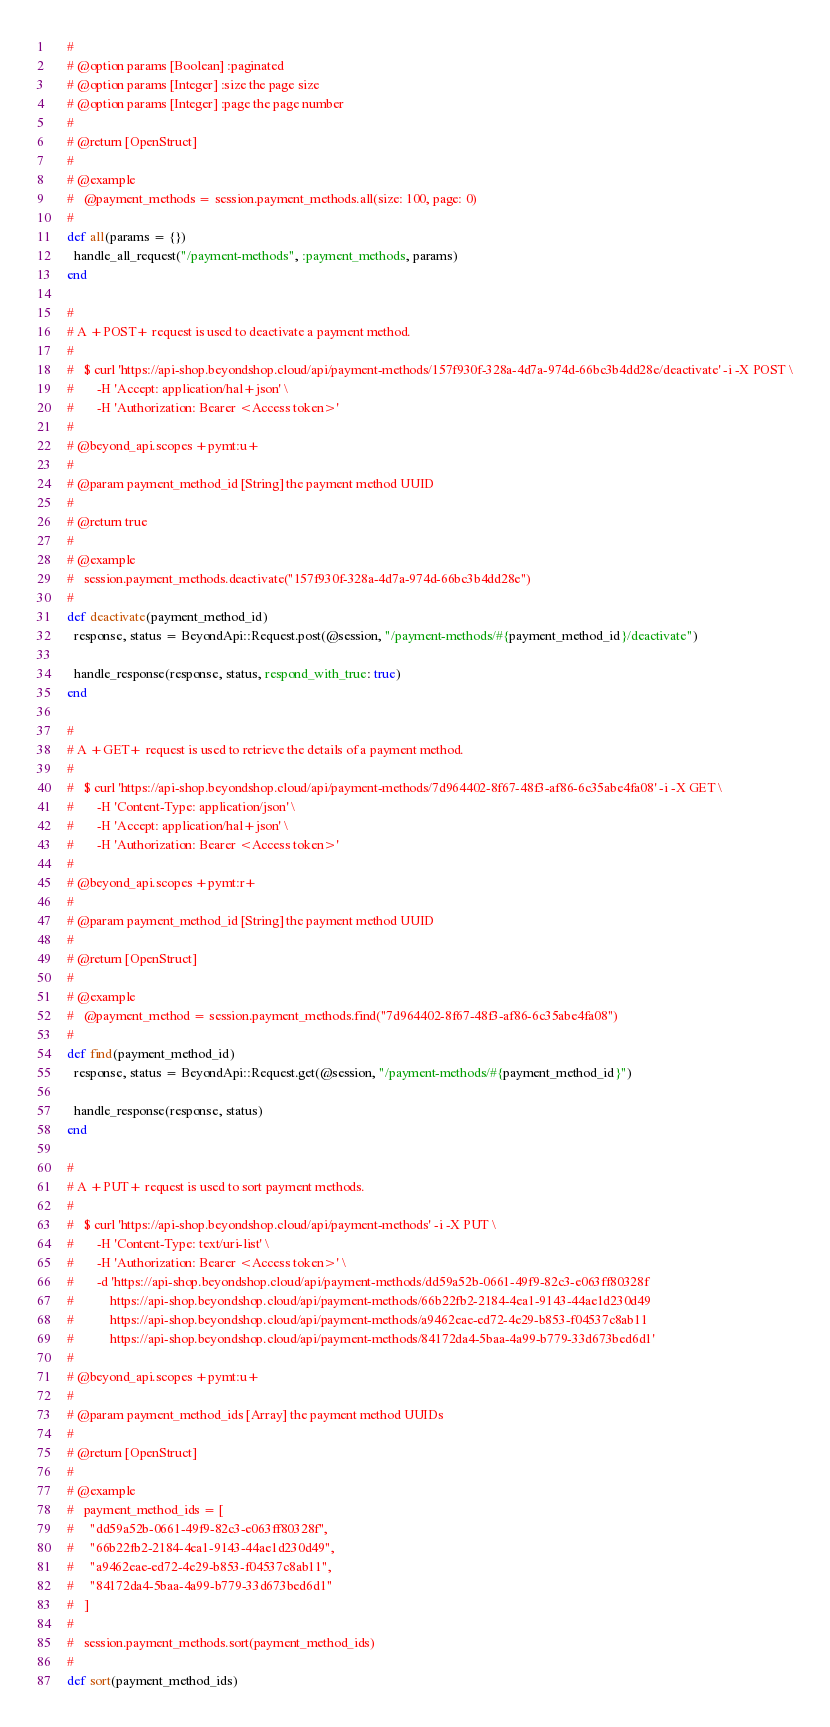<code> <loc_0><loc_0><loc_500><loc_500><_Ruby_>    #
    # @option params [Boolean] :paginated
    # @option params [Integer] :size the page size
    # @option params [Integer] :page the page number
    #
    # @return [OpenStruct]
    #
    # @example
    #   @payment_methods = session.payment_methods.all(size: 100, page: 0)
    #
    def all(params = {})
      handle_all_request("/payment-methods", :payment_methods, params)
    end

    #
    # A +POST+ request is used to deactivate a payment method.
    #
    #   $ curl 'https://api-shop.beyondshop.cloud/api/payment-methods/157f930f-328a-4d7a-974d-66bc3b4dd28e/deactivate' -i -X POST \
    #       -H 'Accept: application/hal+json' \
    #       -H 'Authorization: Bearer <Access token>'
    #
    # @beyond_api.scopes +pymt:u+
    #
    # @param payment_method_id [String] the payment method UUID
    #
    # @return true
    #
    # @example
    #   session.payment_methods.deactivate("157f930f-328a-4d7a-974d-66bc3b4dd28e")
    #
    def deactivate(payment_method_id)
      response, status = BeyondApi::Request.post(@session, "/payment-methods/#{payment_method_id}/deactivate")

      handle_response(response, status, respond_with_true: true)
    end

    #
    # A +GET+ request is used to retrieve the details of a payment method.
    #
    #   $ curl 'https://api-shop.beyondshop.cloud/api/payment-methods/7d964402-8f67-48f3-af86-6c35abe4fa08' -i -X GET \
    #       -H 'Content-Type: application/json' \
    #       -H 'Accept: application/hal+json' \
    #       -H 'Authorization: Bearer <Access token>'
    #
    # @beyond_api.scopes +pymt:r+
    #
    # @param payment_method_id [String] the payment method UUID
    #
    # @return [OpenStruct]
    #
    # @example
    #   @payment_method = session.payment_methods.find("7d964402-8f67-48f3-af86-6c35abe4fa08")
    #
    def find(payment_method_id)
      response, status = BeyondApi::Request.get(@session, "/payment-methods/#{payment_method_id}")

      handle_response(response, status)
    end

    #
    # A +PUT+ request is used to sort payment methods.
    #
    #   $ curl 'https://api-shop.beyondshop.cloud/api/payment-methods' -i -X PUT \
    #       -H 'Content-Type: text/uri-list' \
    #       -H 'Authorization: Bearer <Access token>' \
    #       -d 'https://api-shop.beyondshop.cloud/api/payment-methods/dd59a52b-0661-49f9-82c3-e063ff80328f
    #           https://api-shop.beyondshop.cloud/api/payment-methods/66b22fb2-2184-4ea1-9143-44ae1d230d49
    #           https://api-shop.beyondshop.cloud/api/payment-methods/a9462eae-ed72-4e29-b853-f04537c8ab11
    #           https://api-shop.beyondshop.cloud/api/payment-methods/84172da4-5baa-4a99-b779-33d673bed6d1'
    #
    # @beyond_api.scopes +pymt:u+
    #
    # @param payment_method_ids [Array] the payment method UUIDs
    #
    # @return [OpenStruct]
    #
    # @example
    #   payment_method_ids = [
    #     "dd59a52b-0661-49f9-82c3-e063ff80328f",
    #     "66b22fb2-2184-4ea1-9143-44ae1d230d49",
    #     "a9462eae-ed72-4e29-b853-f04537c8ab11",
    #     "84172da4-5baa-4a99-b779-33d673bed6d1"
    #   ]
    #
    #   session.payment_methods.sort(payment_method_ids)
    #
    def sort(payment_method_ids)</code> 